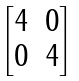<formula> <loc_0><loc_0><loc_500><loc_500>\begin{bmatrix} 4 & 0 \\ 0 & 4 \end{bmatrix}</formula> 